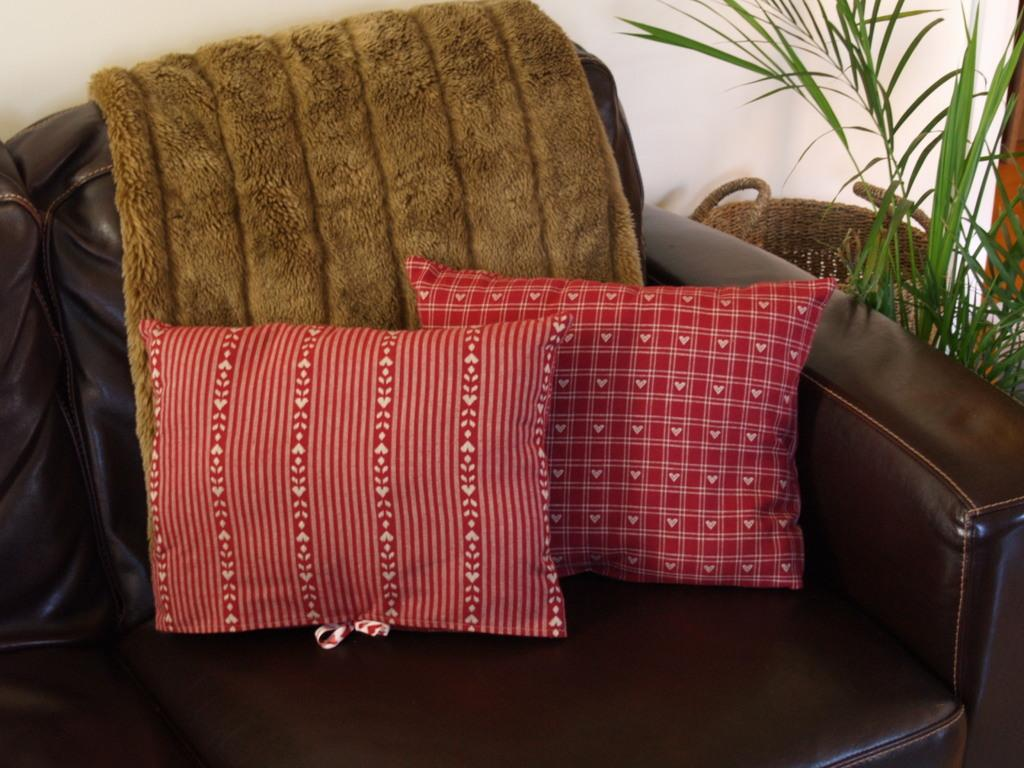What type of furniture is in the image? There is a sofa in the image. What is placed on the sofa? There is a pillow and a towel on the sofa. What can be seen in the background of the image? There is a wall and plants in the background of the image. What type of alley can be seen in the image? There is no alley present in the image. Can you describe the veins of the plants in the image? There are no visible veins in the plants, as the image does not provide a close-up view of the plants. 